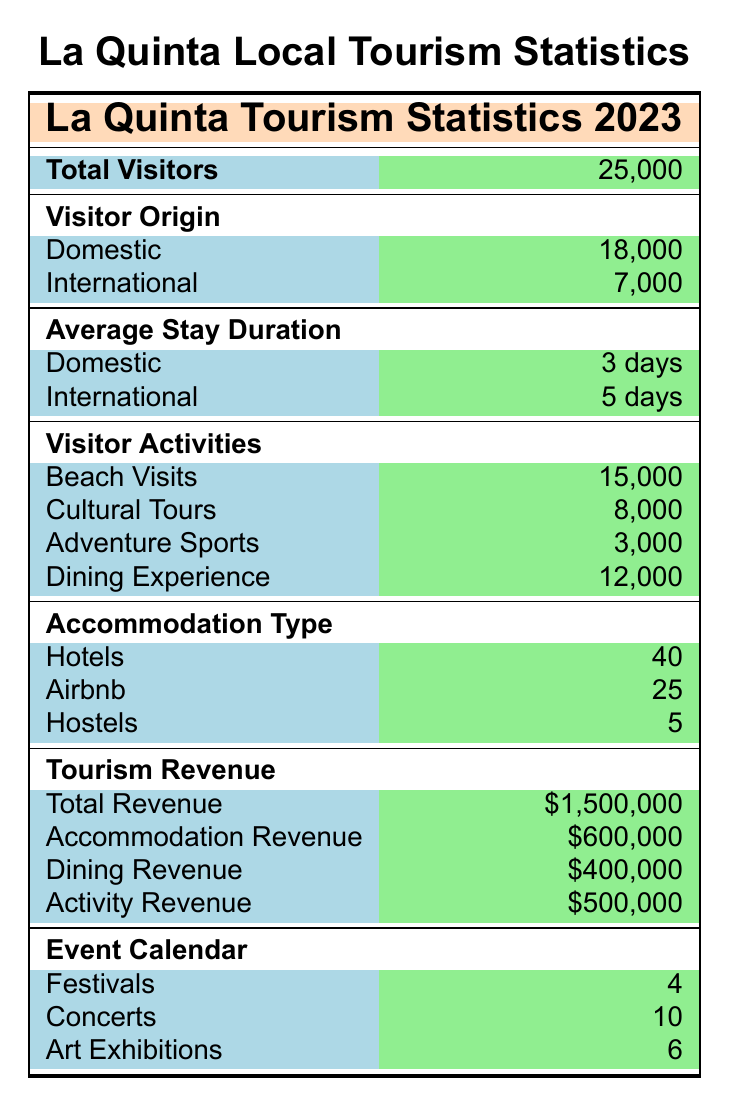What is the total number of visitors to La Quinta in 2023? The total number of visitors is directly stated in the table. It lists "Total Visitors" as 25,000.
Answer: 25,000 What percentage of the visitors were domestic? To find the percentage of domestic visitors, divide the number of domestic visitors (18,000) by the total number of visitors (25,000) and then multiply by 100. The calculation is (18,000 / 25,000) * 100 = 72%.
Answer: 72% Is the average stay duration for international visitors longer than for domestic visitors? The average stay duration for domestic visitors is 3 days while for international visitors it is 5 days. Since 5 days is greater than 3 days, the answer is yes.
Answer: Yes How much revenue did dining experiences generate compared to accommodation revenue? Dining revenue is $400,000 while accommodation revenue is $600,000. To compare, we can see that dining revenue is less than accommodation revenue. Thus, we conclude that dining experiences generated less revenue.
Answer: Dining experiences generated less revenue How many more visitors participated in beach visits compared to adventure sports? Beach visits numbered 15,000 while adventure sports had 3,000 participants. To find the difference, subtract the adventure sports visitors from the beach visitors: 15,000 - 3,000 = 12,000 more beach visitors.
Answer: 12,000 What is the total number of cultural tours and art exhibitions combined? Cultural tours have a total of 8,000 visitors and art exhibitions had 6 events. To find the combined total, we sum the two figures: 8,000 + 6 = 8,006.
Answer: 8,006 How many events were hosted in total (festivals, concerts, and art exhibitions)? The total number of events is the sum of festivals (4), concerts (10), and art exhibitions (6): 4 + 10 + 6 = 20.
Answer: 20 Was the revenue from activities higher than the revenue from dining? The revenue for activities is $500,000 while dining revenue is $400,000. Since $500,000 is greater than $400,000, the revenue from activities was higher.
Answer: Yes What type of accommodation had the least number of listings? The table shows that hostels had only 5 listings, which is less than hotels (40) and Airbnb (25). Thus, hostels had the least number of listings.
Answer: Hostels 